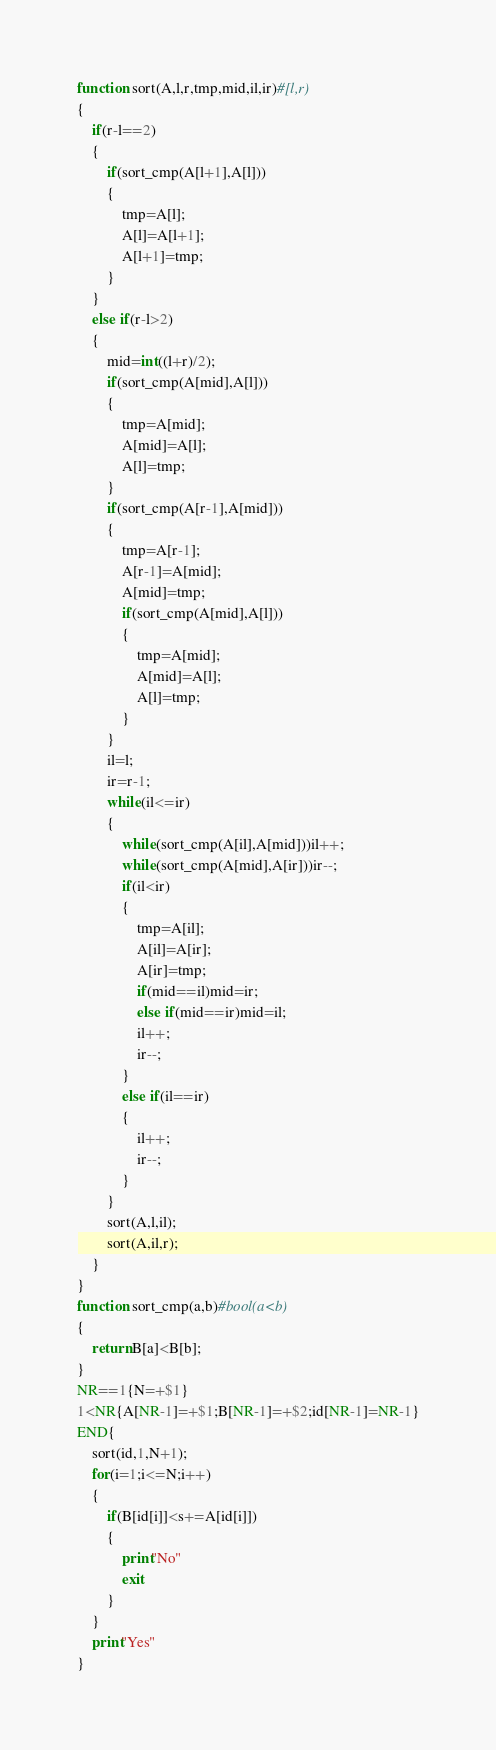Convert code to text. <code><loc_0><loc_0><loc_500><loc_500><_Awk_>function sort(A,l,r,tmp,mid,il,ir)#[l,r)
{
	if(r-l==2)
	{
		if(sort_cmp(A[l+1],A[l]))
		{
			tmp=A[l];
			A[l]=A[l+1];
			A[l+1]=tmp;
		}
	}
	else if(r-l>2)
	{
		mid=int((l+r)/2);
		if(sort_cmp(A[mid],A[l]))
		{
			tmp=A[mid];
			A[mid]=A[l];
			A[l]=tmp;
		}
		if(sort_cmp(A[r-1],A[mid]))
		{
			tmp=A[r-1];
			A[r-1]=A[mid];
			A[mid]=tmp;
			if(sort_cmp(A[mid],A[l]))
			{
				tmp=A[mid];
				A[mid]=A[l];
				A[l]=tmp;
			}
		}
		il=l;
		ir=r-1;
		while(il<=ir)
		{
			while(sort_cmp(A[il],A[mid]))il++;
			while(sort_cmp(A[mid],A[ir]))ir--;
			if(il<ir)
			{
				tmp=A[il];
				A[il]=A[ir];
				A[ir]=tmp;
				if(mid==il)mid=ir;
				else if(mid==ir)mid=il;
				il++;
				ir--;
			}
			else if(il==ir)
			{
				il++;
				ir--;
			}
		}
		sort(A,l,il);
		sort(A,il,r);
	}
}
function sort_cmp(a,b)#bool(a<b)
{
	return B[a]<B[b];
}
NR==1{N=+$1}
1<NR{A[NR-1]=+$1;B[NR-1]=+$2;id[NR-1]=NR-1}
END{
	sort(id,1,N+1);
	for(i=1;i<=N;i++)
	{
		if(B[id[i]]<s+=A[id[i]])
		{
			print"No"
			exit
		}
	}
	print"Yes"
}
</code> 